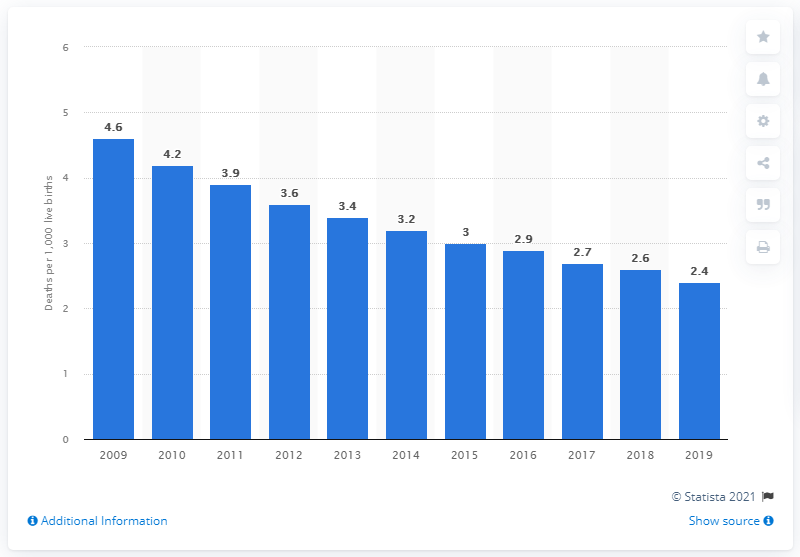Identify some key points in this picture. In 2019, the infant mortality rate in Belarus was 2.4 per 1,000 live births. 